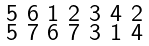Convert formula to latex. <formula><loc_0><loc_0><loc_500><loc_500>\begin{smallmatrix} 5 & 6 & 1 & 2 & 3 & 4 & 2 \\ 5 & 7 & 6 & 7 & 3 & 1 & 4 \end{smallmatrix}</formula> 